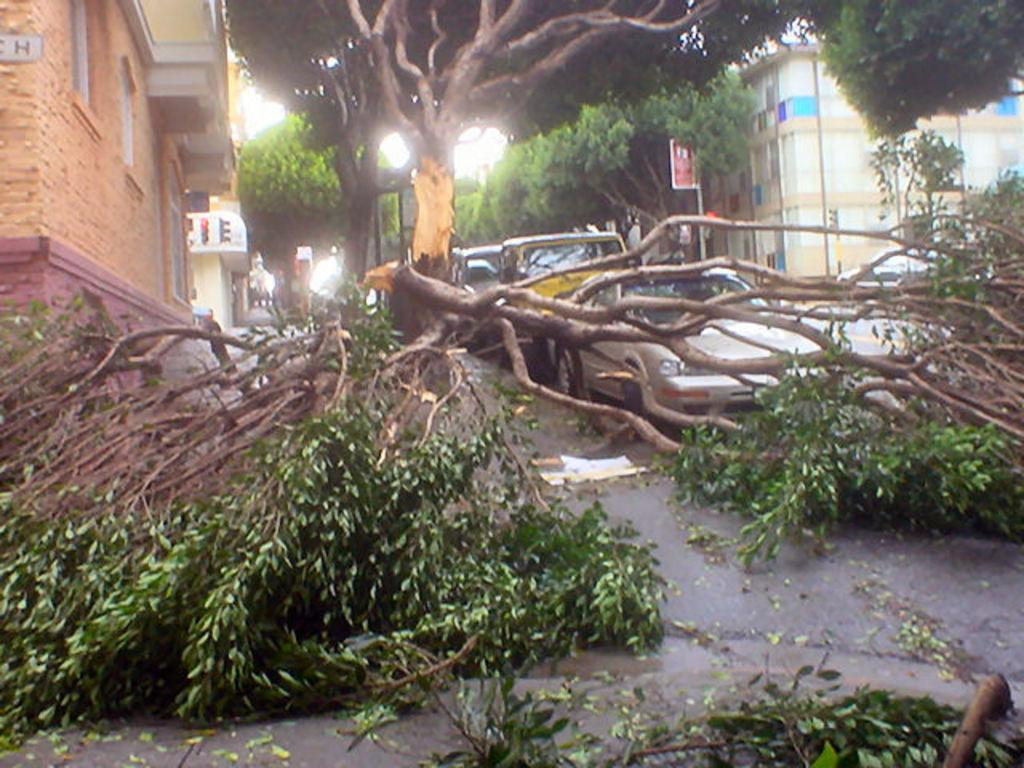What is blocking the road in the image? Trees that have been cut and felled are blocking the road in the image. What else can be seen on the road in the image? Vehicles are parked on the road. What type of structures are visible in the image? There are buildings visible in the image. What else is present in the image besides the trees and buildings? Boards are visible in the image. What type of furniture can be seen in the image? There is no furniture present in the image. Can you tell me how many teeth the judge has in the image? There is no judge or any reference to teeth in the image. 